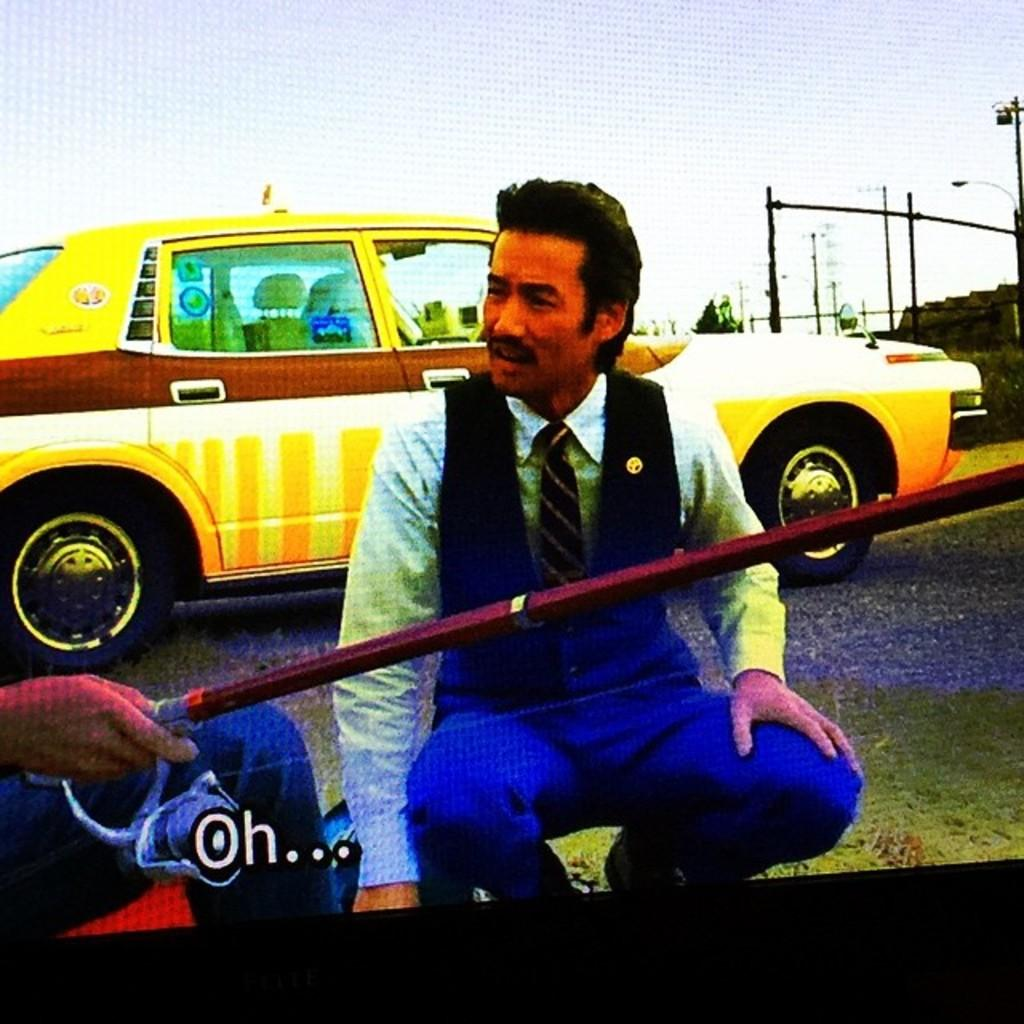<image>
Render a clear and concise summary of the photo. A man is squatting in front of a car with the subtitle "Oh..." shown below him. 